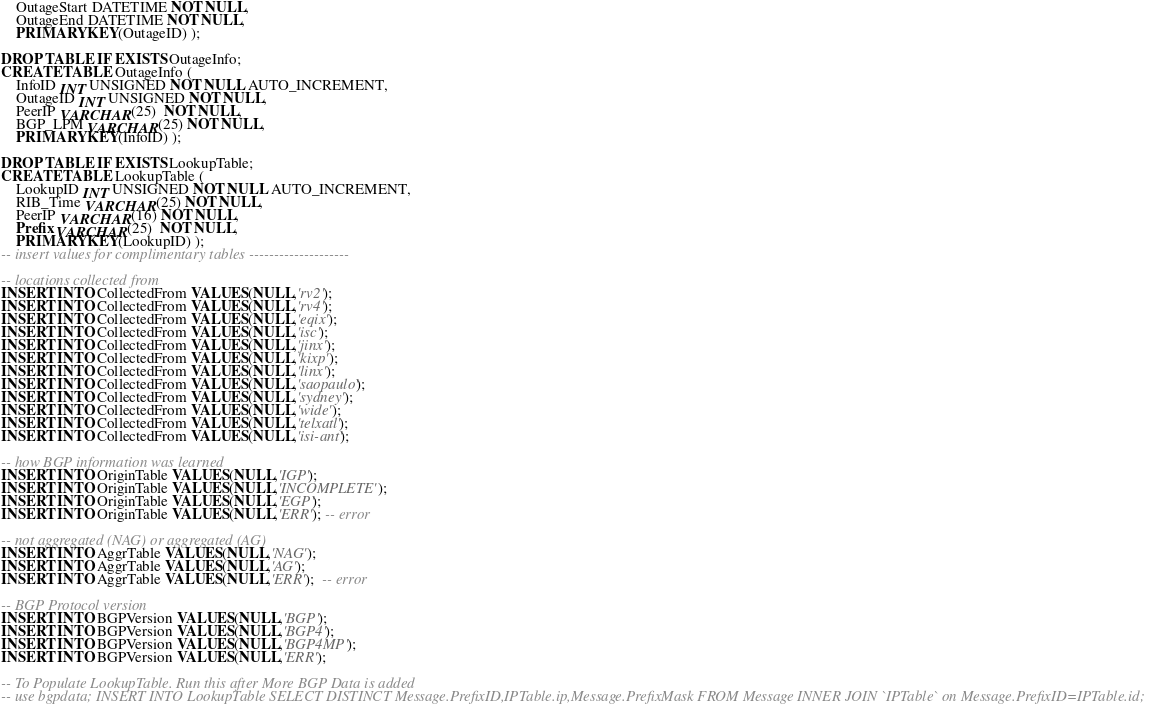Convert code to text. <code><loc_0><loc_0><loc_500><loc_500><_SQL_>	OutageStart DATETIME NOT NULL,
	OutageEnd DATETIME NOT NULL,
	PRIMARY KEY(OutageID) );

DROP TABLE IF EXISTS OutageInfo;
CREATE TABLE OutageInfo (
	InfoID INT UNSIGNED NOT NULL AUTO_INCREMENT,
	OutageID INT UNSIGNED NOT NULL,
	PeerIP VARCHAR(25)  NOT NULL,
	BGP_LPM VARCHAR(25) NOT NULL,
	PRIMARY KEY(InfoID) );

DROP TABLE IF EXISTS LookupTable;
CREATE TABLE LookupTable (
	LookupID INT UNSIGNED NOT NULL AUTO_INCREMENT,
	RIB_Time VARCHAR(25) NOT NULL,
	PeerIP VARCHAR(16) NOT NULL,
	Prefix VARCHAR(25)  NOT NULL,
	PRIMARY KEY(LookupID) );
-- insert values for complimentary tables --------------------

-- locations collected from
INSERT INTO CollectedFrom VALUES(NULL,'rv2');
INSERT INTO CollectedFrom VALUES(NULL,'rv4');
INSERT INTO CollectedFrom VALUES(NULL,'eqix');
INSERT INTO CollectedFrom VALUES(NULL,'isc');
INSERT INTO CollectedFrom VALUES(NULL,'jinx');
INSERT INTO CollectedFrom VALUES(NULL,'kixp');
INSERT INTO CollectedFrom VALUES(NULL,'linx');
INSERT INTO CollectedFrom VALUES(NULL,'saopaulo');
INSERT INTO CollectedFrom VALUES(NULL,'sydney');
INSERT INTO CollectedFrom VALUES(NULL,'wide');
INSERT INTO CollectedFrom VALUES(NULL,'telxatl');
INSERT INTO CollectedFrom VALUES(NULL,'isi-ant');

-- how BGP information was learned
INSERT INTO OriginTable VALUES(NULL,'IGP');
INSERT INTO OriginTable VALUES(NULL,'INCOMPLETE');
INSERT INTO OriginTable VALUES(NULL,'EGP');
INSERT INTO OriginTable VALUES(NULL,'ERR'); -- error

-- not aggregated (NAG) or aggregated (AG)
INSERT INTO AggrTable VALUES(NULL,'NAG');
INSERT INTO AggrTable VALUES(NULL,'AG');
INSERT INTO AggrTable VALUES(NULL,'ERR');  -- error

-- BGP Protocol version
INSERT INTO BGPVersion VALUES(NULL,'BGP');
INSERT INTO BGPVersion VALUES(NULL,'BGP4');
INSERT INTO BGPVersion VALUES(NULL,'BGP4MP');
INSERT INTO BGPVersion VALUES(NULL,'ERR');

-- To Populate LookupTable. Run this after More BGP Data is added
-- use bgpdata; INSERT INTO LookupTable SELECT DISTINCT Message.PrefixID,IPTable.ip,Message.PrefixMask FROM Message INNER JOIN `IPTable` on Message.PrefixID=IPTable.id;
</code> 